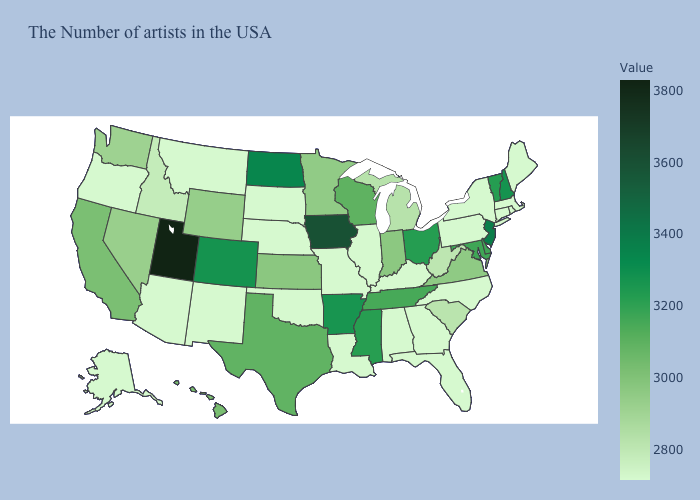Among the states that border Tennessee , which have the lowest value?
Quick response, please. North Carolina, Georgia, Kentucky, Alabama, Missouri. Among the states that border Oregon , does California have the highest value?
Concise answer only. Yes. Does Louisiana have the highest value in the South?
Answer briefly. No. Among the states that border Connecticut , which have the highest value?
Write a very short answer. Massachusetts, Rhode Island, New York. Does New Jersey have a lower value than Wyoming?
Give a very brief answer. No. Is the legend a continuous bar?
Concise answer only. Yes. 